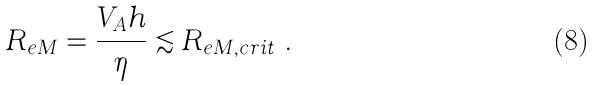Convert formula to latex. <formula><loc_0><loc_0><loc_500><loc_500>R _ { e M } = \frac { V _ { A } h } { \eta } \lesssim R _ { e M , c r i t } \ .</formula> 